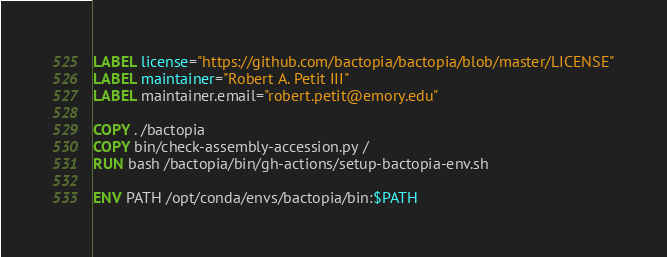<code> <loc_0><loc_0><loc_500><loc_500><_Dockerfile_>LABEL license="https://github.com/bactopia/bactopia/blob/master/LICENSE"
LABEL maintainer="Robert A. Petit III"
LABEL maintainer.email="robert.petit@emory.edu"

COPY . /bactopia
COPY bin/check-assembly-accession.py /
RUN bash /bactopia/bin/gh-actions/setup-bactopia-env.sh

ENV PATH /opt/conda/envs/bactopia/bin:$PATH
</code> 